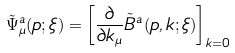Convert formula to latex. <formula><loc_0><loc_0><loc_500><loc_500>\tilde { \Psi } _ { \mu } ^ { a } ( p ; \xi ) = \left [ { \frac { \partial } { \partial k _ { \mu } } } \tilde { B } ^ { a } ( p , k ; \xi ) \right ] _ { k = 0 }</formula> 